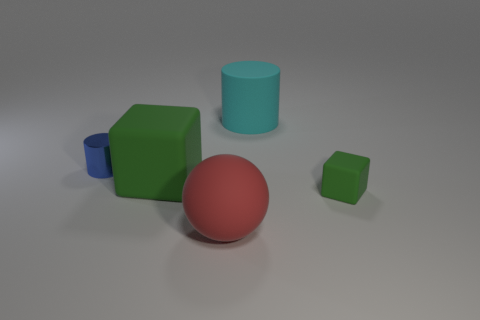Is there anything else that has the same material as the blue cylinder?
Ensure brevity in your answer.  No. Does the block on the left side of the matte sphere have the same size as the big cyan matte cylinder?
Provide a short and direct response. Yes. How many cyan blocks are the same size as the ball?
Provide a succinct answer. 0. What size is the rubber thing that is the same color as the big rubber block?
Give a very brief answer. Small. Does the tiny cube have the same color as the big block?
Give a very brief answer. Yes. What is the shape of the large red rubber object?
Keep it short and to the point. Sphere. Is there a big metal ball that has the same color as the tiny metallic cylinder?
Ensure brevity in your answer.  No. Is the number of small green cubes in front of the cyan rubber cylinder greater than the number of yellow metallic objects?
Your answer should be compact. Yes. There is a small blue shiny object; is its shape the same as the green matte object right of the large rubber sphere?
Make the answer very short. No. Is there a brown metallic sphere?
Provide a succinct answer. No. 